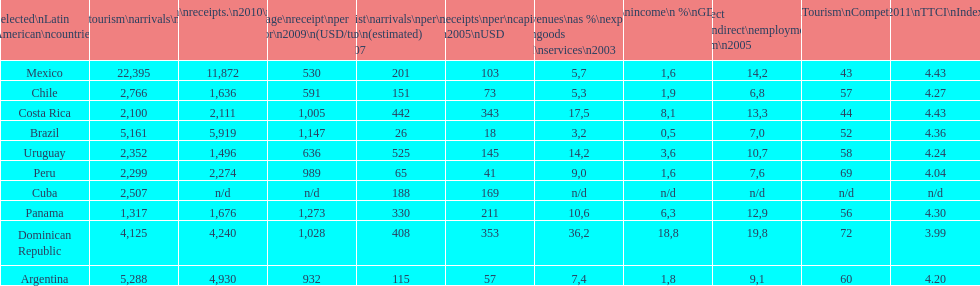How many dollars on average did brazil receive per tourist in 2009? 1,147. 